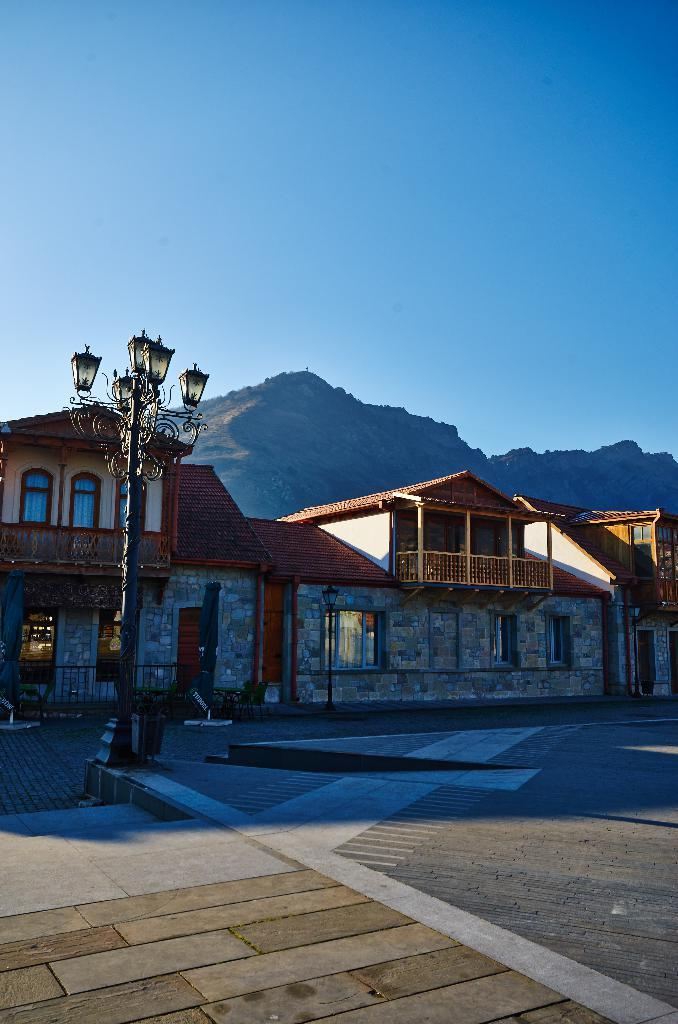What type of structures can be seen in the image? There are houses in the image. What type of lighting is present in the image? Pole lights are visible in the image. What geographical feature is present in the image? There is a hill in the image. What color is the sky in the image? The sky is blue in the image. Can you tell me where the duck is located in the image? There is no duck present in the image. In which direction are the houses facing in the image? The provided facts do not specify the direction the houses are facing, so we cannot determine that information from the image. 